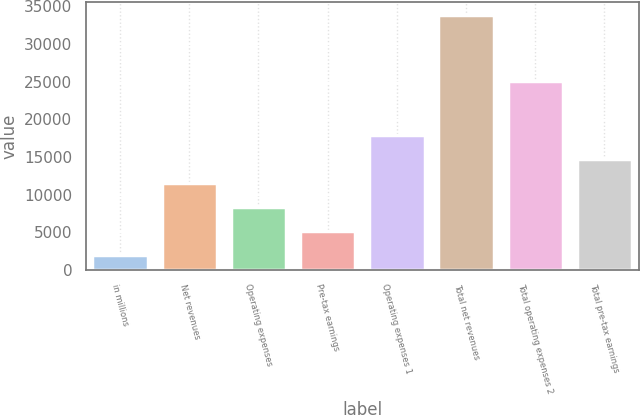Convert chart. <chart><loc_0><loc_0><loc_500><loc_500><bar_chart><fcel>in millions<fcel>Net revenues<fcel>Operating expenses<fcel>Pre-tax earnings<fcel>Operating expenses 1<fcel>Total net revenues<fcel>Total operating expenses 2<fcel>Total pre-tax earnings<nl><fcel>2015<fcel>11556.5<fcel>8376<fcel>5195.5<fcel>17917.5<fcel>33820<fcel>25042<fcel>14737<nl></chart> 